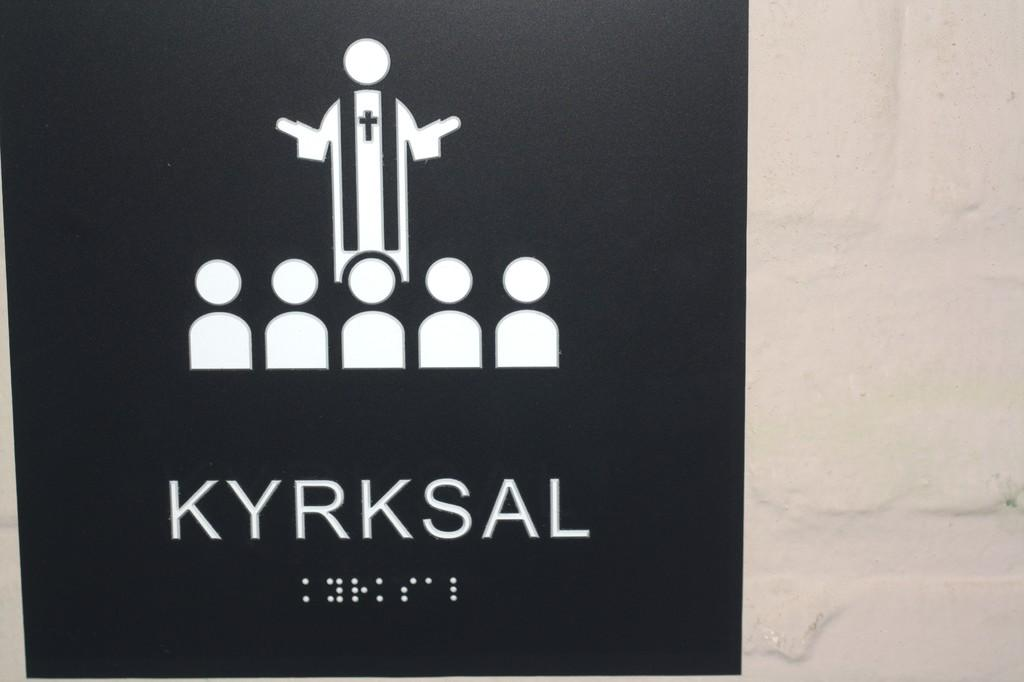<image>
Relay a brief, clear account of the picture shown. A sign in braille that says Kyrksal above the braille. 